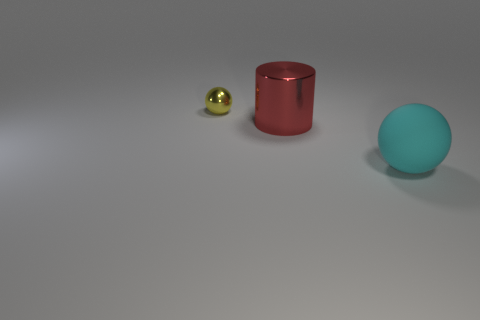Is there anything else that has the same size as the yellow metal ball?
Offer a terse response. No. Is there anything else that is made of the same material as the big ball?
Your answer should be very brief. No. How many other things are there of the same size as the cylinder?
Offer a very short reply. 1. What is the size of the thing that is in front of the tiny yellow object and behind the large ball?
Your answer should be very brief. Large. How many large objects are metallic cylinders or cyan spheres?
Offer a very short reply. 2. There is a large thing that is to the right of the red metallic thing; what shape is it?
Offer a terse response. Sphere. How many balls are there?
Your response must be concise. 2. Are the tiny object and the red cylinder made of the same material?
Provide a succinct answer. Yes. Are there more large metallic things in front of the large cylinder than big red metal cylinders?
Your response must be concise. No. What number of objects are either small metallic spheres or metal things in front of the small yellow thing?
Keep it short and to the point. 2. 